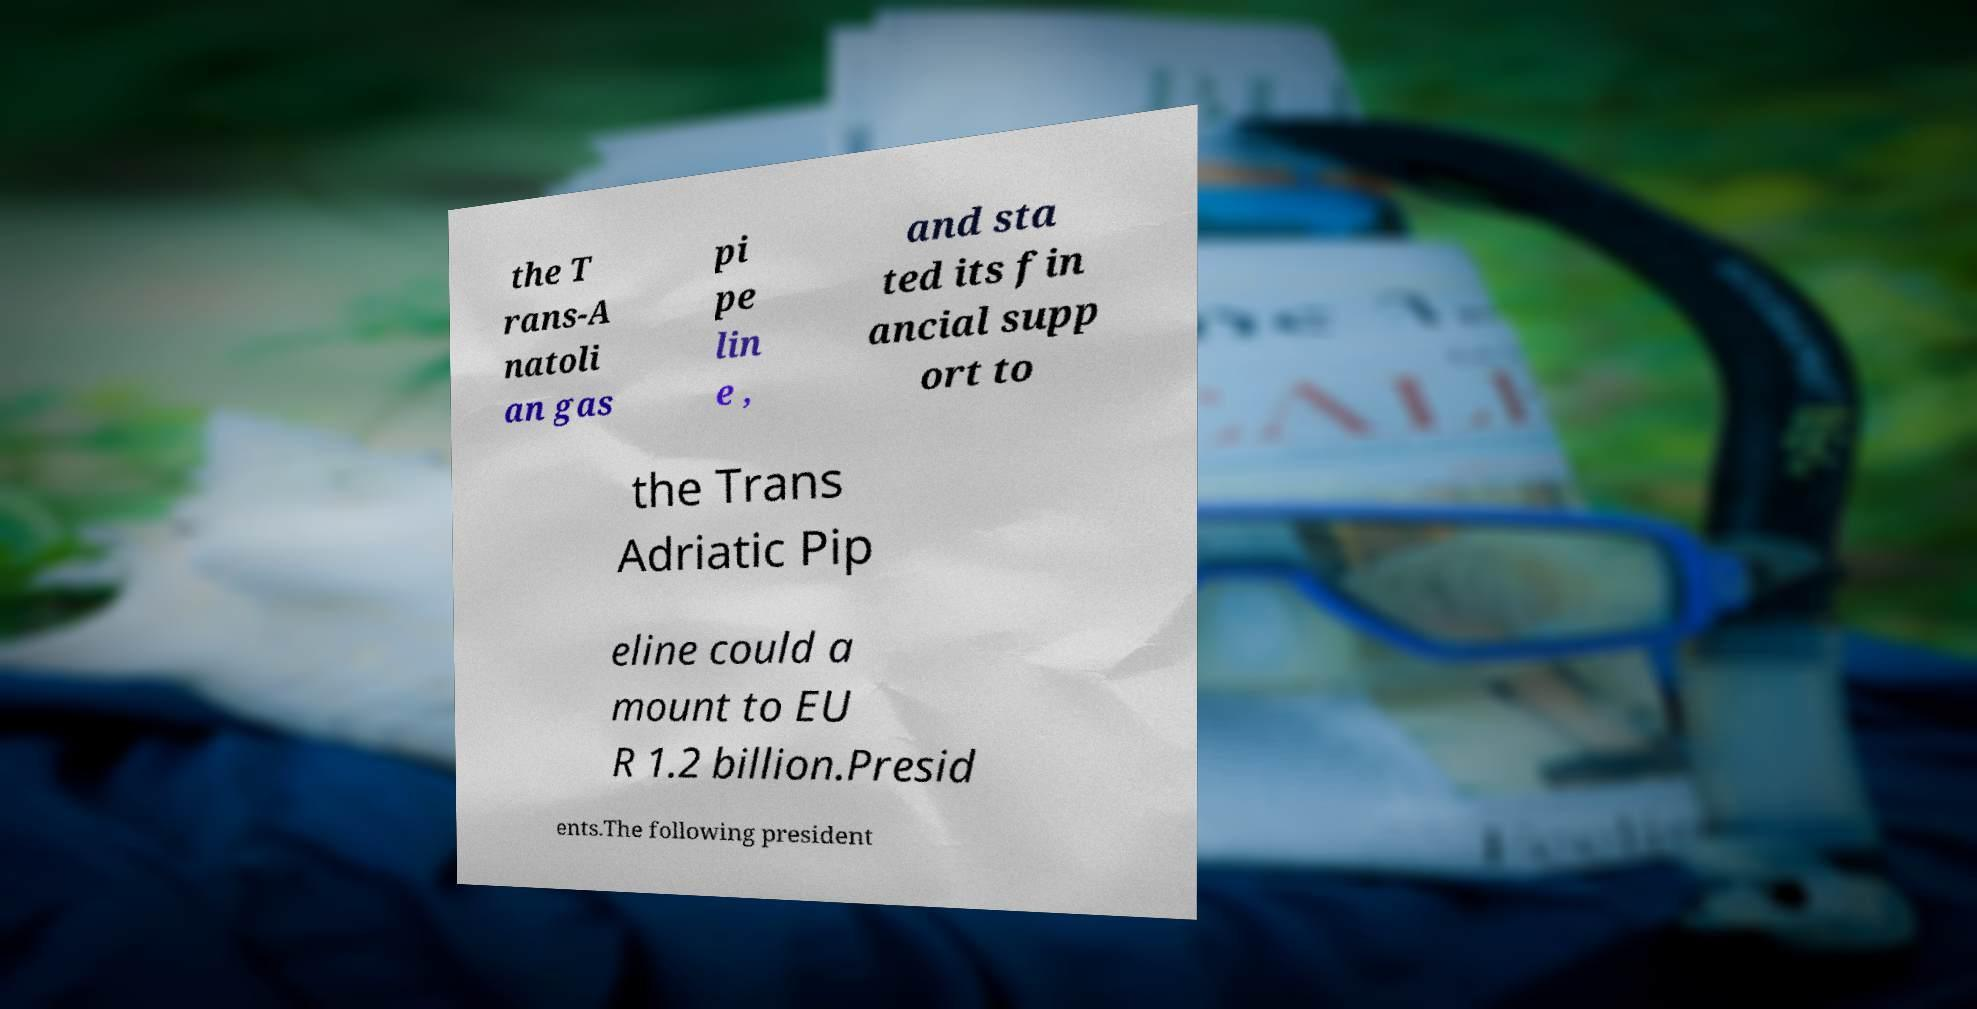I need the written content from this picture converted into text. Can you do that? the T rans-A natoli an gas pi pe lin e , and sta ted its fin ancial supp ort to the Trans Adriatic Pip eline could a mount to EU R 1.2 billion.Presid ents.The following president 